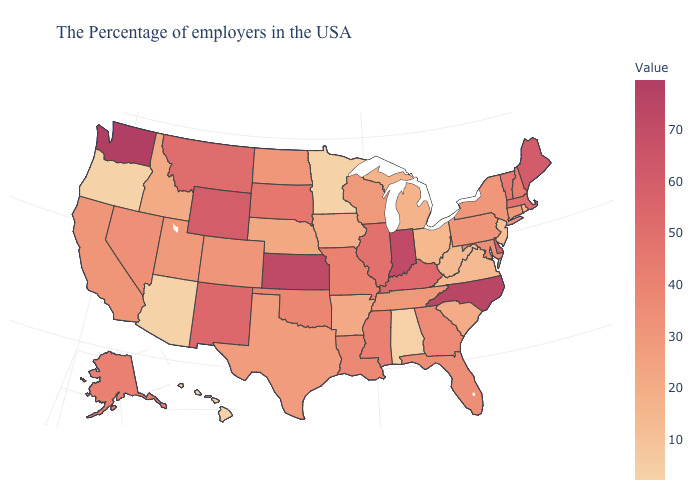Which states have the lowest value in the USA?
Write a very short answer. Minnesota, Arizona, Oregon, Hawaii. Which states hav the highest value in the West?
Concise answer only. Washington. Which states hav the highest value in the South?
Quick response, please. North Carolina. Among the states that border Nevada , which have the lowest value?
Quick response, please. Arizona, Oregon. Among the states that border New Mexico , which have the lowest value?
Concise answer only. Arizona. Does Hawaii have the highest value in the West?
Concise answer only. No. Does Hawaii have the lowest value in the USA?
Quick response, please. Yes. Among the states that border Minnesota , does Wisconsin have the highest value?
Concise answer only. No. Among the states that border Nevada , which have the highest value?
Give a very brief answer. California. Which states hav the highest value in the Northeast?
Keep it brief. Maine. Which states have the lowest value in the South?
Answer briefly. Alabama. 